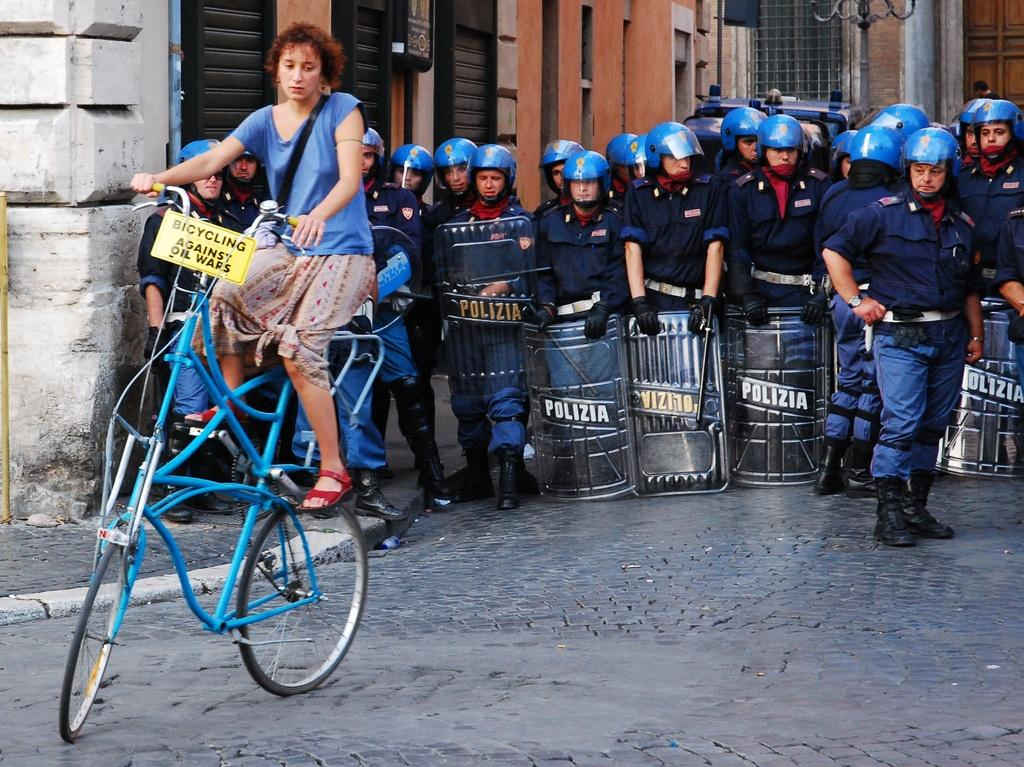How many people are in the image? There is a group of people in the image. What is one person doing in the image? One person is riding a bicycle a bicycle. What is attached to the bicycle? A board is attached to the bicycle. What can be seen in the background of the image? There is a building in the background of the image. What type of glue is being used by the person riding the bicycle in the image? There is no glue present in the image, and the person riding the bicycle is not using any glue. What kind of notebook is being held by the person riding the bicycle in the image? There is no notebook present in the image, and the person riding the bicycle is not holding any notebook. 